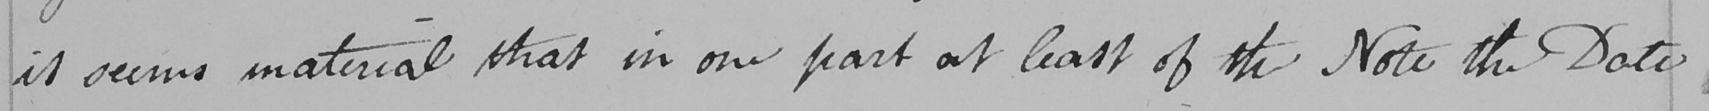What does this handwritten line say? it seems material that in one part at least of the Note the Date 